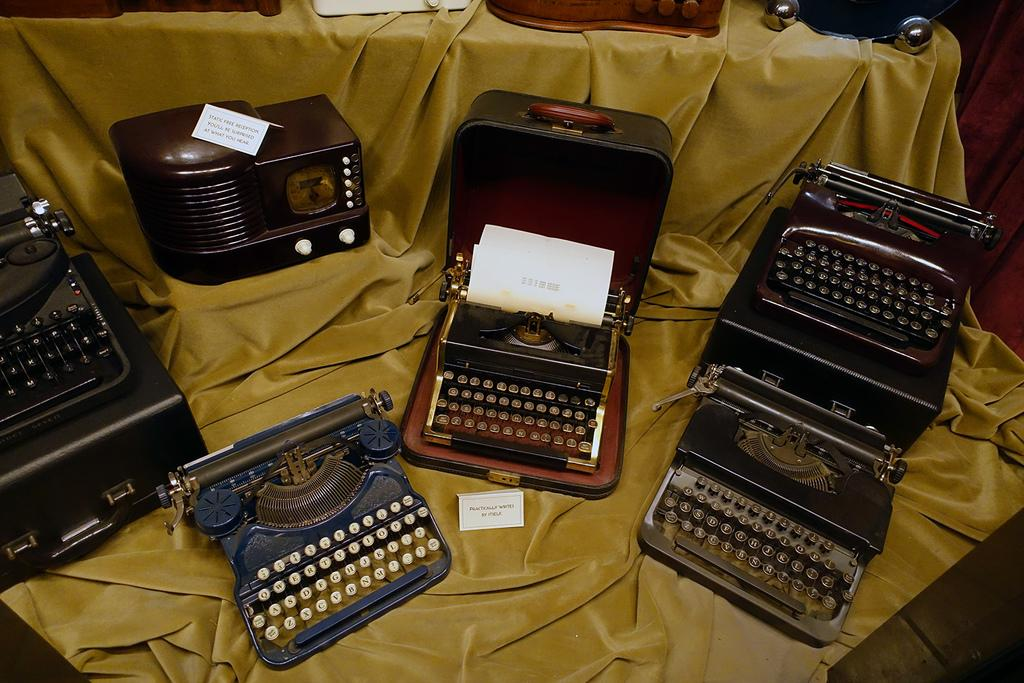What type of machines are present in the image? There are typing machines in the image. What other objects can be seen in the image besides the typing machines? There are boards and objects on cloth in the image. How many faucets are visible in the image? There are no faucets present in the image. 